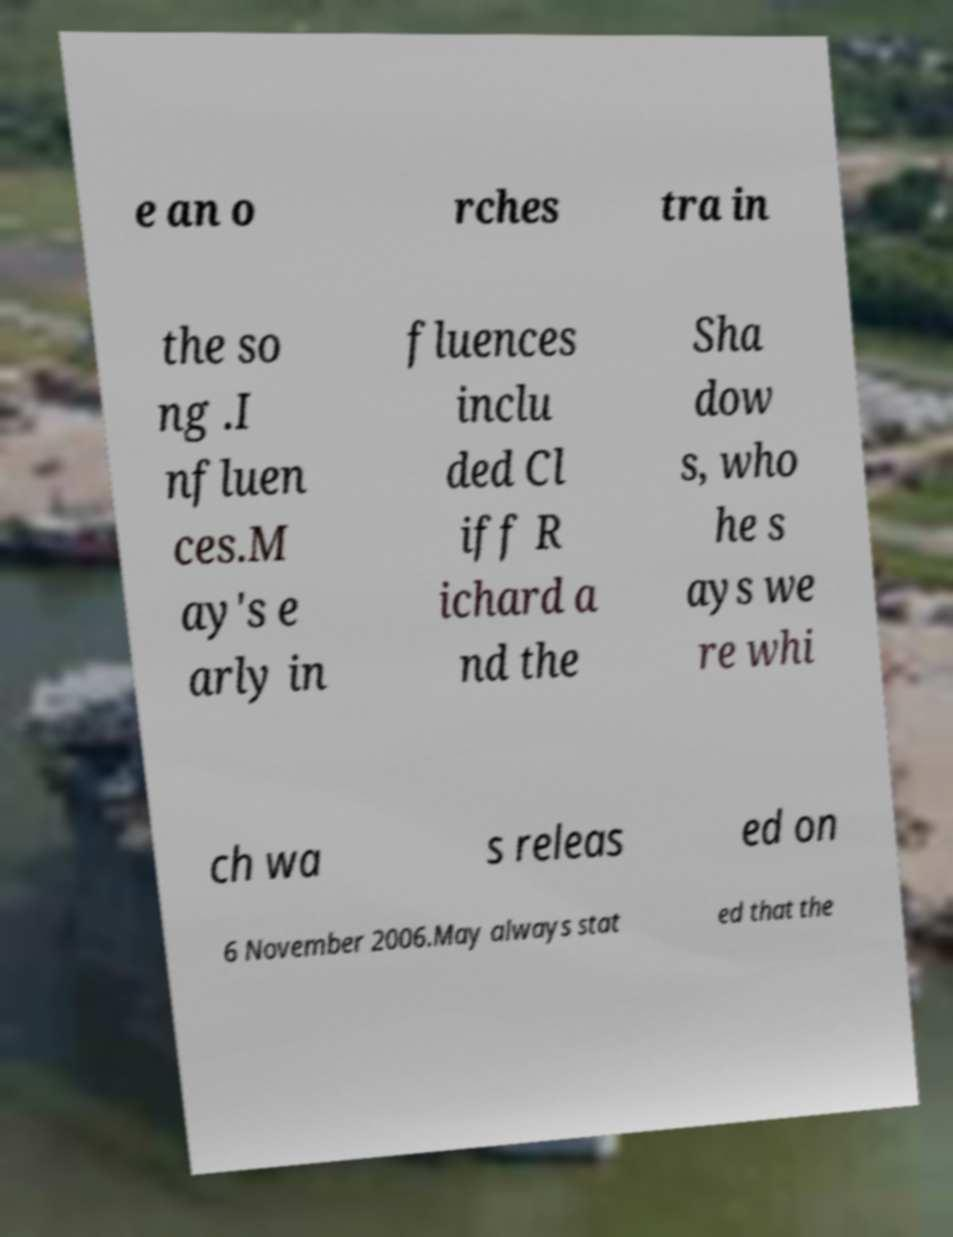Can you accurately transcribe the text from the provided image for me? e an o rches tra in the so ng .I nfluen ces.M ay's e arly in fluences inclu ded Cl iff R ichard a nd the Sha dow s, who he s ays we re whi ch wa s releas ed on 6 November 2006.May always stat ed that the 